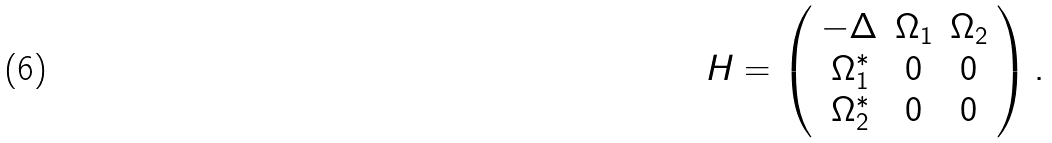<formula> <loc_0><loc_0><loc_500><loc_500>H = \left ( \begin{array} { c c c } - \Delta & \Omega _ { 1 } & \Omega _ { 2 } \\ \Omega _ { 1 } ^ { * } & 0 & 0 \\ \Omega _ { 2 } ^ { * } & 0 & 0 \end{array} \right ) .</formula> 